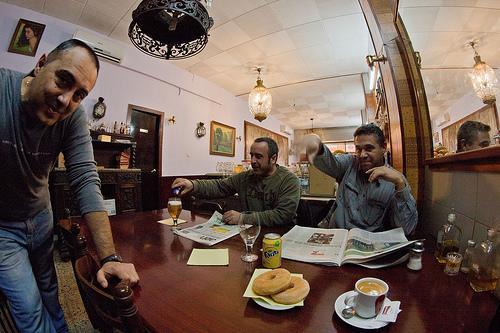How many people are in the picture?
Give a very brief answer. 3. 